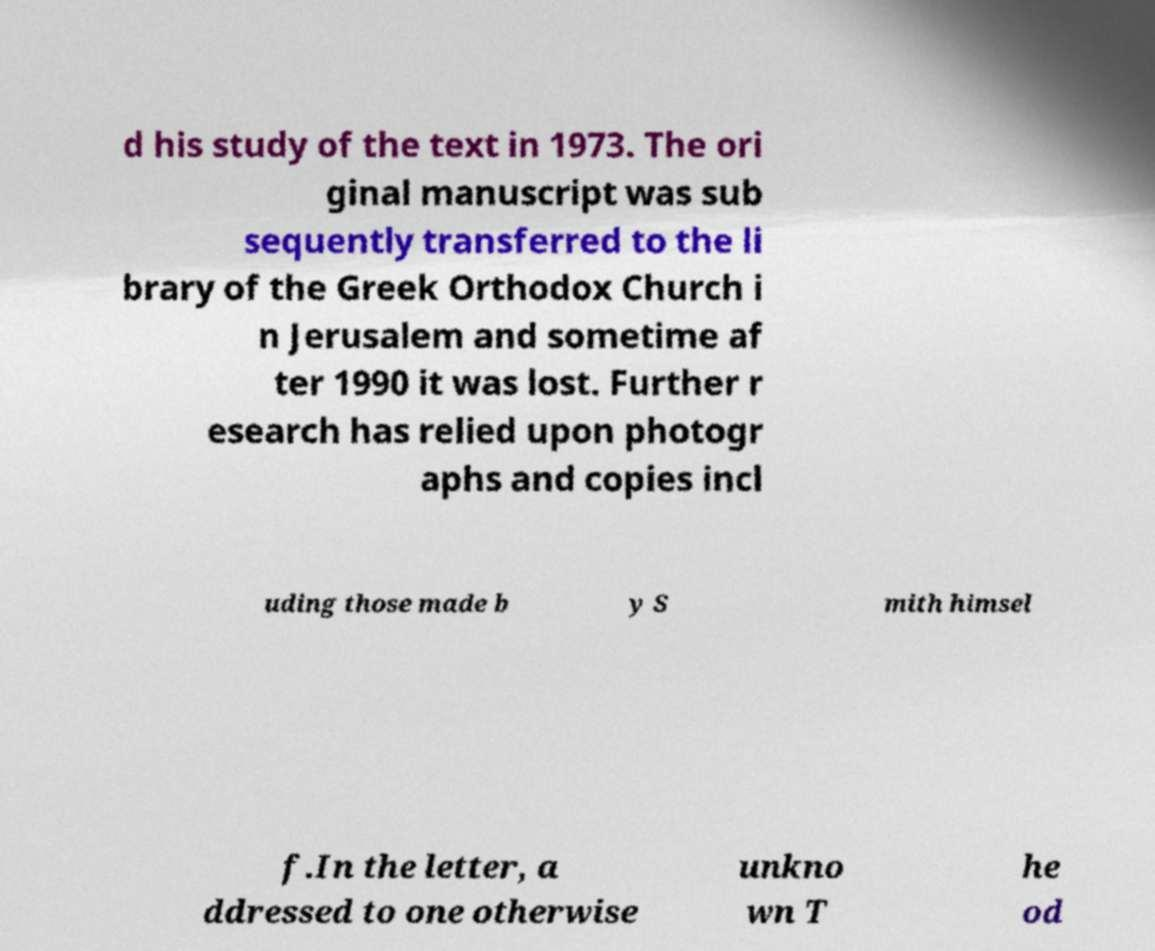Can you read and provide the text displayed in the image?This photo seems to have some interesting text. Can you extract and type it out for me? d his study of the text in 1973. The ori ginal manuscript was sub sequently transferred to the li brary of the Greek Orthodox Church i n Jerusalem and sometime af ter 1990 it was lost. Further r esearch has relied upon photogr aphs and copies incl uding those made b y S mith himsel f.In the letter, a ddressed to one otherwise unkno wn T he od 